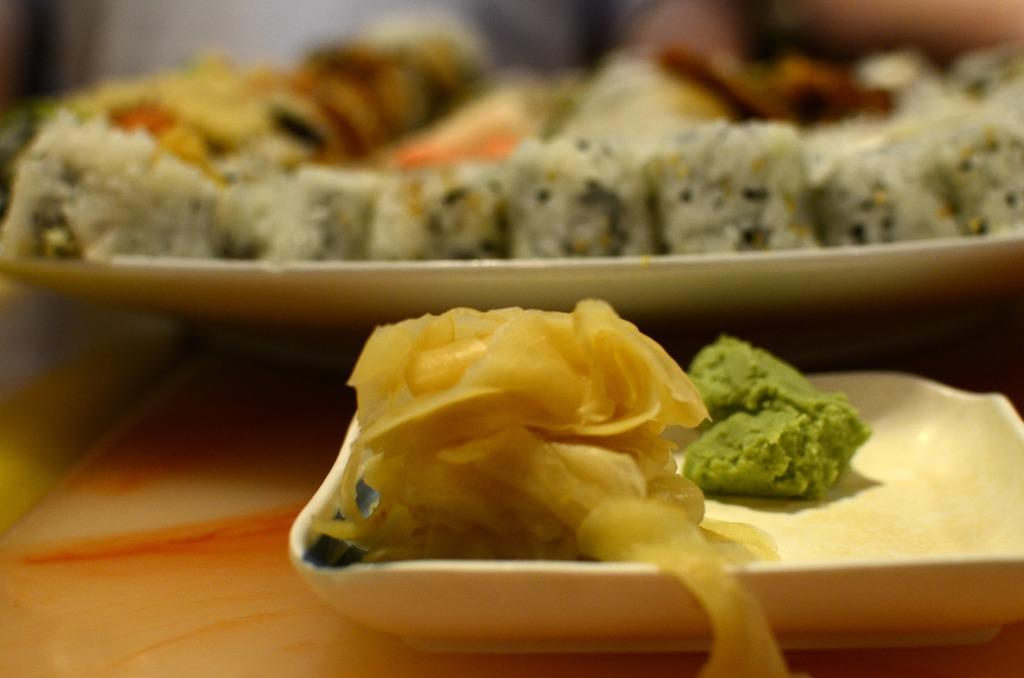What can be seen on the plates in the image? Food items are served on plates in the image. How many plates are visible in the image? The number of plates cannot be determined from the provided facts. What type of food items can be seen on the plates? The specific type of food items cannot be determined from the provided facts. Are there any horses or dinosaurs visible in the image? No, there are no horses or dinosaurs present in the image. How many cherries can be seen on the plates in the image? The number of cherries cannot be determined from the provided facts, as the specific type of food items is not mentioned. 